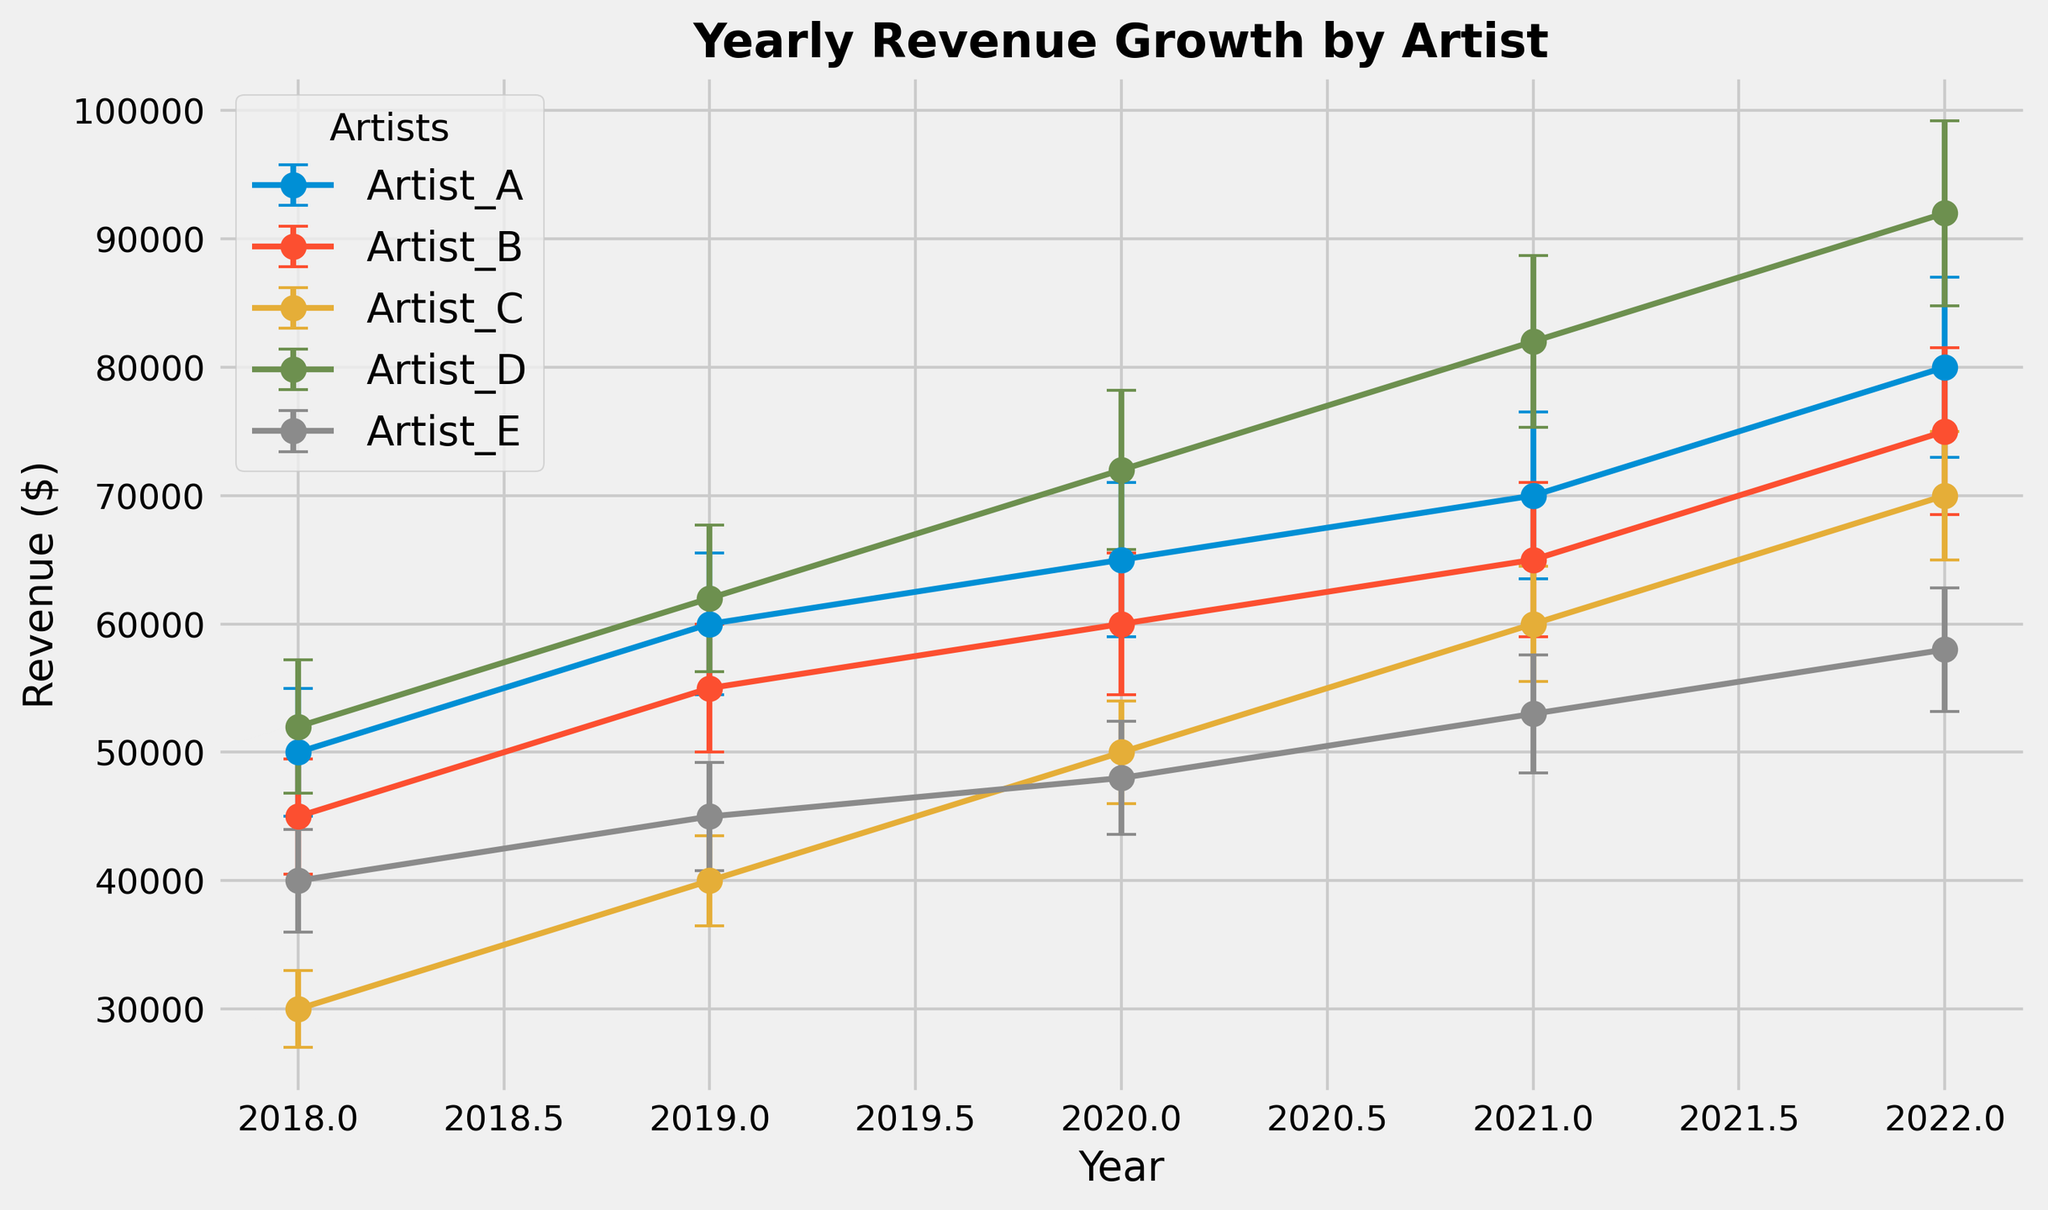Which artist had the highest revenue in 2022? By looking at the "Yearly Revenue Growth by Artist" chart, find the data point for 2022 for each artist and identify the highest revenue.
Answer: Artist_D Which artist showed the most consistent revenue growth over the years from 2018 to 2022? Evaluate the visual trend of the revenue lines for each artist from 2018 to 2022. The artist with the least variability and a clearly upward trend demonstrates consistent growth.
Answer: Artist_E Compare the revenue for Artist_A and Artist_B in 2021. Which artist had higher revenue and by how much? Locate the revenue data points for 2021 for both Artist_A and Artist_B. Subtract the lower value from the higher value to find the difference.
Answer: Artist_A by $5000 What is the average revenue for Artist_C over the years 2018 to 2022? Add up the revenue values for Artist_C from 2018 to 2022 and divide by the number of years (5) to find the average.
Answer: $50000 Identify the year with the highest standard deviation (StdDev) in revenue for Artist_D. Find the highest y-axis error bar for Artist_D. Note the year corresponding to this data point.
Answer: 2022 Which year showed the smallest revenue difference between Artist_A and Artist_E? For each year from 2018 to 2022, compute the absolute difference in revenue between Artist_A and Artist_E. Identify the year with the smallest difference.
Answer: 2018 By what percentage did Artist_B's revenue increase from 2018 to 2022? Calculate the percentage increase by using the formula: ((Revenue in 2022 - Revenue in 2018) / Revenue in 2018) * 100%.
Answer: 66.67% Which artist had the steepest revenue growth between any two consecutive years? Examine the slopes of the revenue lines between each pair of consecutive years for all artists. The steepest slope will denote the largest revenue growth between two consecutive years.
Answer: Artist_D (between 2021 and 2022) Was there any year when Artist_C's revenue surpassed Artist_A's revenue? Compare the revenue values of Artist_C to Artist_A for each year from 2018 to 2022. Determine if there is any year where Artist_C's value is greater.
Answer: No What is the total combined revenue for all artists in the year 2020? Sum the revenue values for all artists in the year 2020.
Answer: $295000 ​​ 